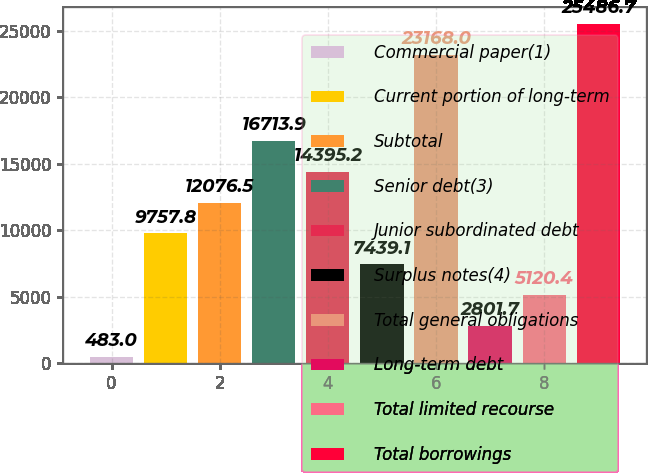<chart> <loc_0><loc_0><loc_500><loc_500><bar_chart><fcel>Commercial paper(1)<fcel>Current portion of long-term<fcel>Subtotal<fcel>Senior debt(3)<fcel>Junior subordinated debt<fcel>Surplus notes(4)<fcel>Total general obligations<fcel>Long-term debt<fcel>Total limited recourse<fcel>Total borrowings<nl><fcel>483<fcel>9757.8<fcel>12076.5<fcel>16713.9<fcel>14395.2<fcel>7439.1<fcel>23168<fcel>2801.7<fcel>5120.4<fcel>25486.7<nl></chart> 